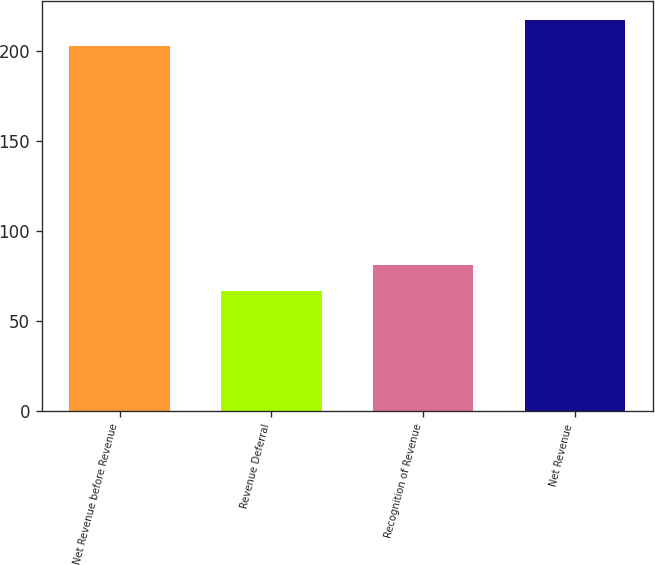Convert chart. <chart><loc_0><loc_0><loc_500><loc_500><bar_chart><fcel>Net Revenue before Revenue<fcel>Revenue Deferral<fcel>Recognition of Revenue<fcel>Net Revenue<nl><fcel>203<fcel>67<fcel>81.4<fcel>217.4<nl></chart> 